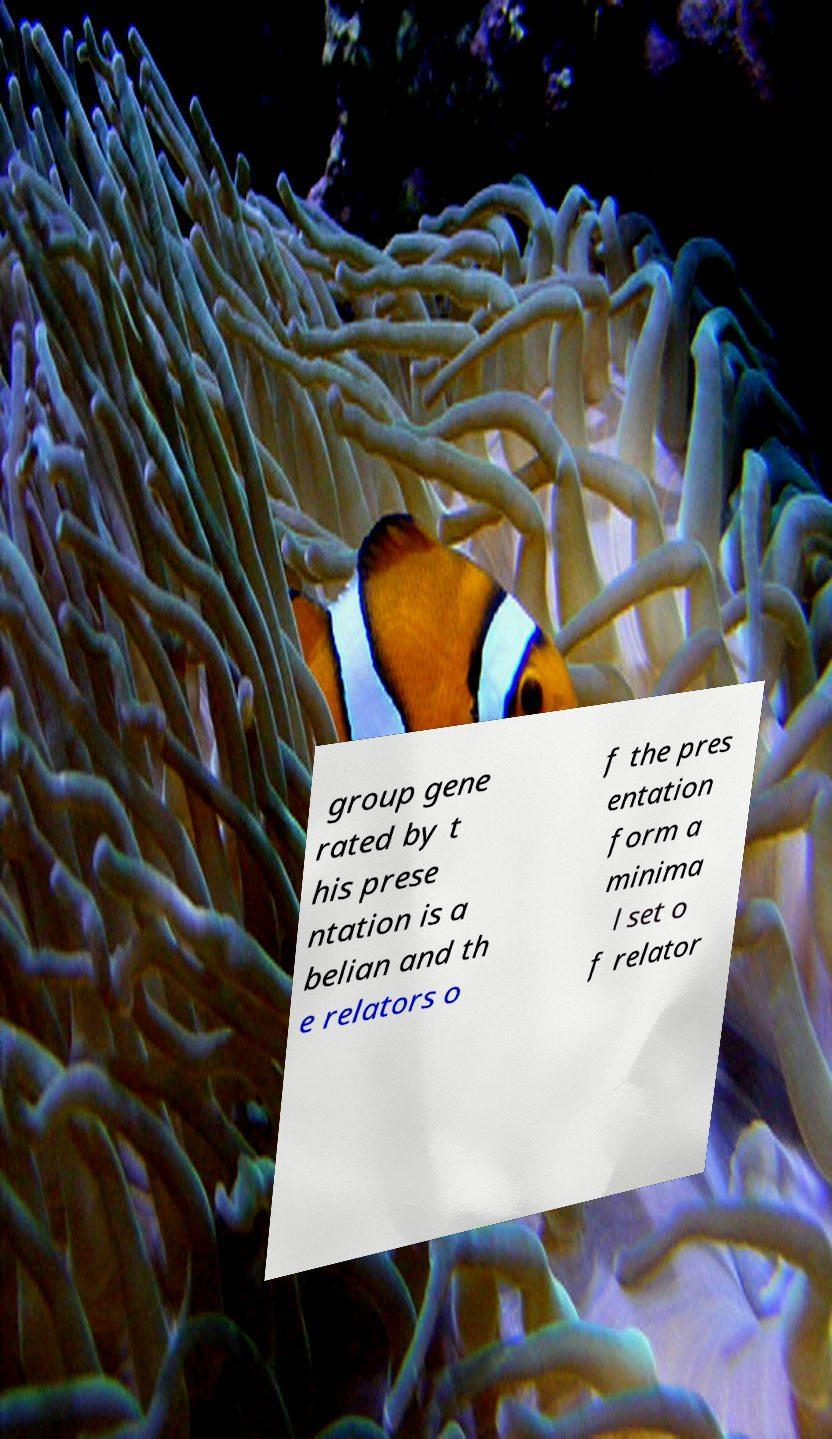Please read and relay the text visible in this image. What does it say? group gene rated by t his prese ntation is a belian and th e relators o f the pres entation form a minima l set o f relator 